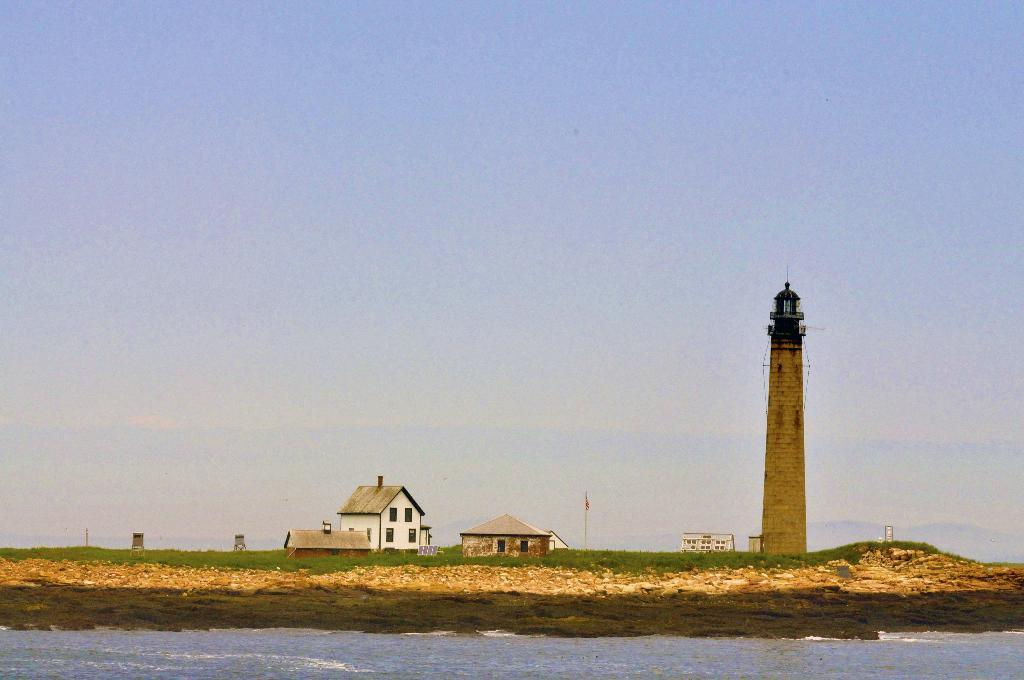What structure is located on the right side of the image? There is a lighthouse on the right side of the image. What type of structures can be seen in the image besides the lighthouse? There are buildings in the image. What natural feature is visible in the image? There is an ocean visible in the image. What is the condition of the sky in the image? The sky is clear in the image. Can you tell me how many lamps are being held by the parent in the image? There is no parent or lamp present in the image; it features a lighthouse, buildings, an ocean, and a clear sky. 